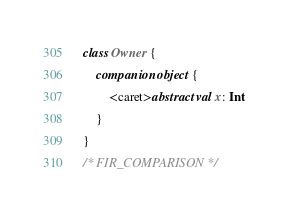<code> <loc_0><loc_0><loc_500><loc_500><_Kotlin_>
class Owner {
    companion object {
        <caret>abstract val x: Int
    }
}
/* FIR_COMPARISON */</code> 